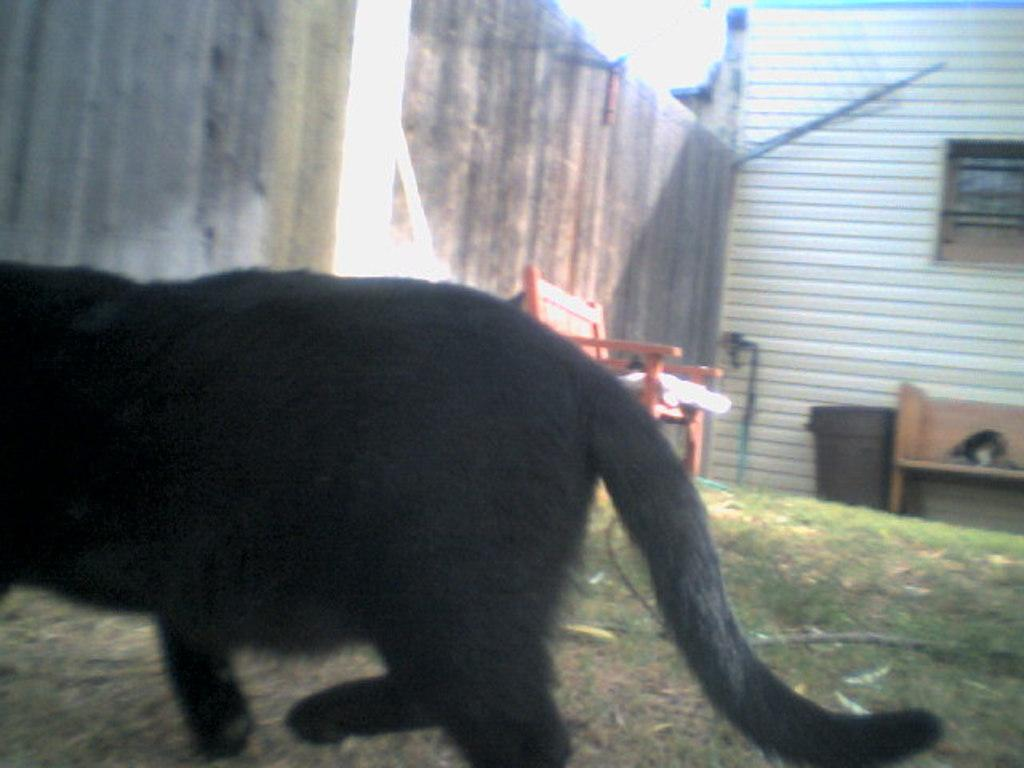What type of animal is in the image? There is an animal in the image, and it is black in color. Where is the animal located in the image? The animal is on the ground in the image. What type of furniture is present in the image? There is a chair and a bench in the image. What color is the object that matches the animal's color? There is a black colored object in the image. What type of structure is visible in the image? There is a wall and a house in the image. What other objects can be seen in the image? There are other objects in the image, but their specific details are not mentioned in the provided facts. How many mice are climbing on the vessel in the image? There are no mice or vessels present in the image. What type of guide is helping the animal in the image? There is no guide present in the image, and the animal does not require assistance. 